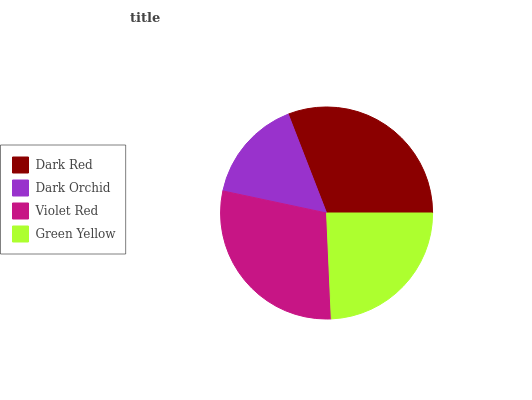Is Dark Orchid the minimum?
Answer yes or no. Yes. Is Dark Red the maximum?
Answer yes or no. Yes. Is Violet Red the minimum?
Answer yes or no. No. Is Violet Red the maximum?
Answer yes or no. No. Is Violet Red greater than Dark Orchid?
Answer yes or no. Yes. Is Dark Orchid less than Violet Red?
Answer yes or no. Yes. Is Dark Orchid greater than Violet Red?
Answer yes or no. No. Is Violet Red less than Dark Orchid?
Answer yes or no. No. Is Violet Red the high median?
Answer yes or no. Yes. Is Green Yellow the low median?
Answer yes or no. Yes. Is Dark Red the high median?
Answer yes or no. No. Is Dark Red the low median?
Answer yes or no. No. 